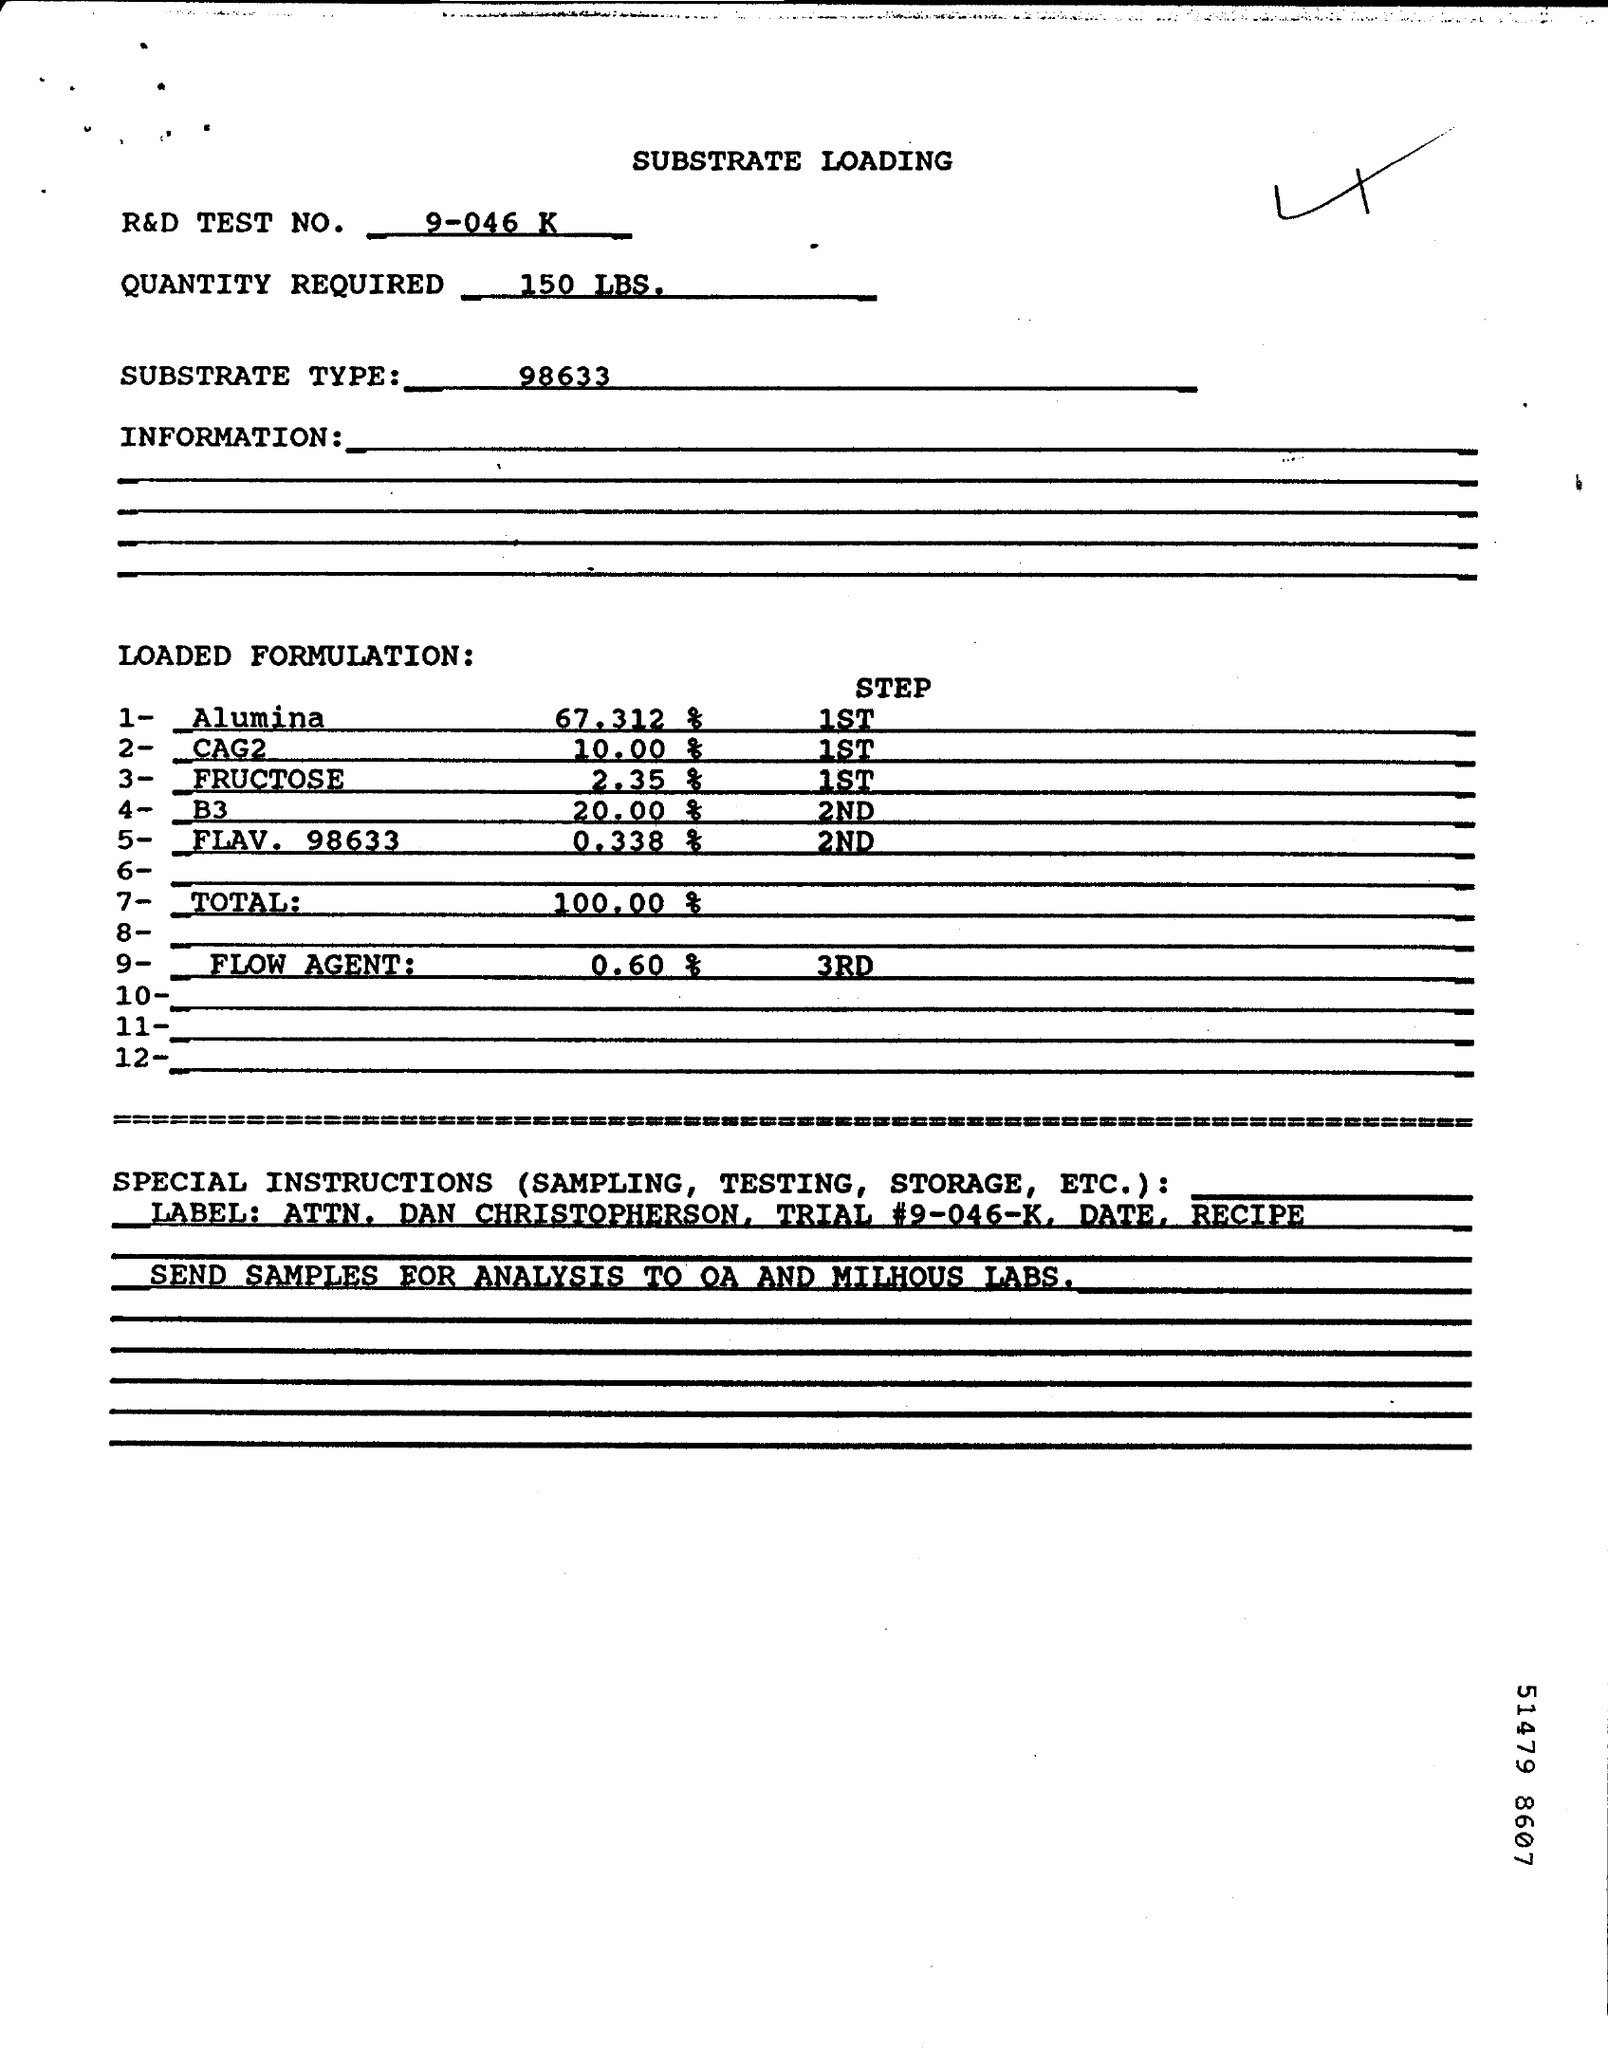Point out several critical features in this image. The required quantity is 150 LBS as per the document. The R&D Test No. given in the document is 9-046 K... The document mentions a type of substrate, which is 98633. 